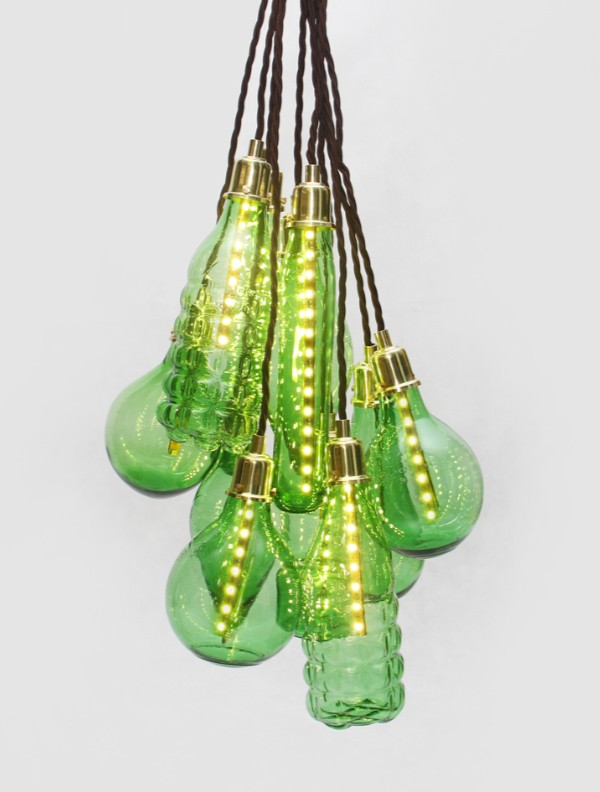Could these lights be used in an outdoor setting, and if so, what would be the impact? Absolutely, these light fixtures could be used in an outdoor setting, and they would create a magical and enchanting atmosphere. Their green glass and organic forms would harmonize beautifully with garden elements, weaving seamlessly among trees, shrubs, and flowers. The soft, warm glow from the LEDs would cast an inviting and intimate light, perfect for evening gatherings or tranquil solitude under the night sky. Imagine these fixtures hanging from tree branches, gently swaying with the breeze, their light casting dappled reflections like fireflies and adding to the natural charm of the surroundings. Such a setup would not only illuminate but also transform the garden into a whimsical haven, evoking a sense of wonder and serenity.  What if these lights had a hidden secret, perhaps an unspoken bond with the moonlight? Imagine if these lights harbored a secret connection with the moon itself. Crafted by a forgotten civilization that revered lunar forces, the fixtures could awaken each night, synchronizing with the moon's phases. On full moon nights, they would glow with unparalleled brilliance, channeling lunar energy to create an otherworldly ambience. On new moon nights, their light would dim to a subtle glow, encouraging introspection and tranquility. These fixtures could even relay ancient lunar messages through subtle changes in their light patterns, providing guidance or inspiration to those attuned to their mystical whispers. Thus, these light fixtures would serve not just as sources of illumination, but as guardians of ancient lunar secrets, silently bridging the realms of earth and sky. 